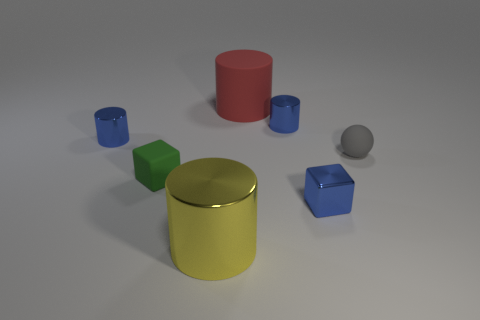What is the shape of the small rubber thing to the right of the tiny green matte block?
Your answer should be very brief. Sphere. What number of other things are the same shape as the red object?
Offer a terse response. 3. Is the material of the object in front of the tiny blue cube the same as the small ball?
Your answer should be compact. No. Are there the same number of shiny blocks that are on the right side of the tiny gray ball and tiny shiny cylinders that are to the left of the large yellow object?
Ensure brevity in your answer.  No. There is a blue cylinder that is on the left side of the big shiny cylinder; how big is it?
Keep it short and to the point. Small. Is there a block that has the same material as the large red thing?
Make the answer very short. Yes. Is the color of the metal cylinder right of the red cylinder the same as the small metallic block?
Your response must be concise. Yes. Are there the same number of small green objects to the right of the small gray sphere and big blue cylinders?
Your answer should be compact. Yes. Are there any tiny spheres that have the same color as the rubber cube?
Ensure brevity in your answer.  No. Is the metal block the same size as the yellow object?
Offer a terse response. No. 